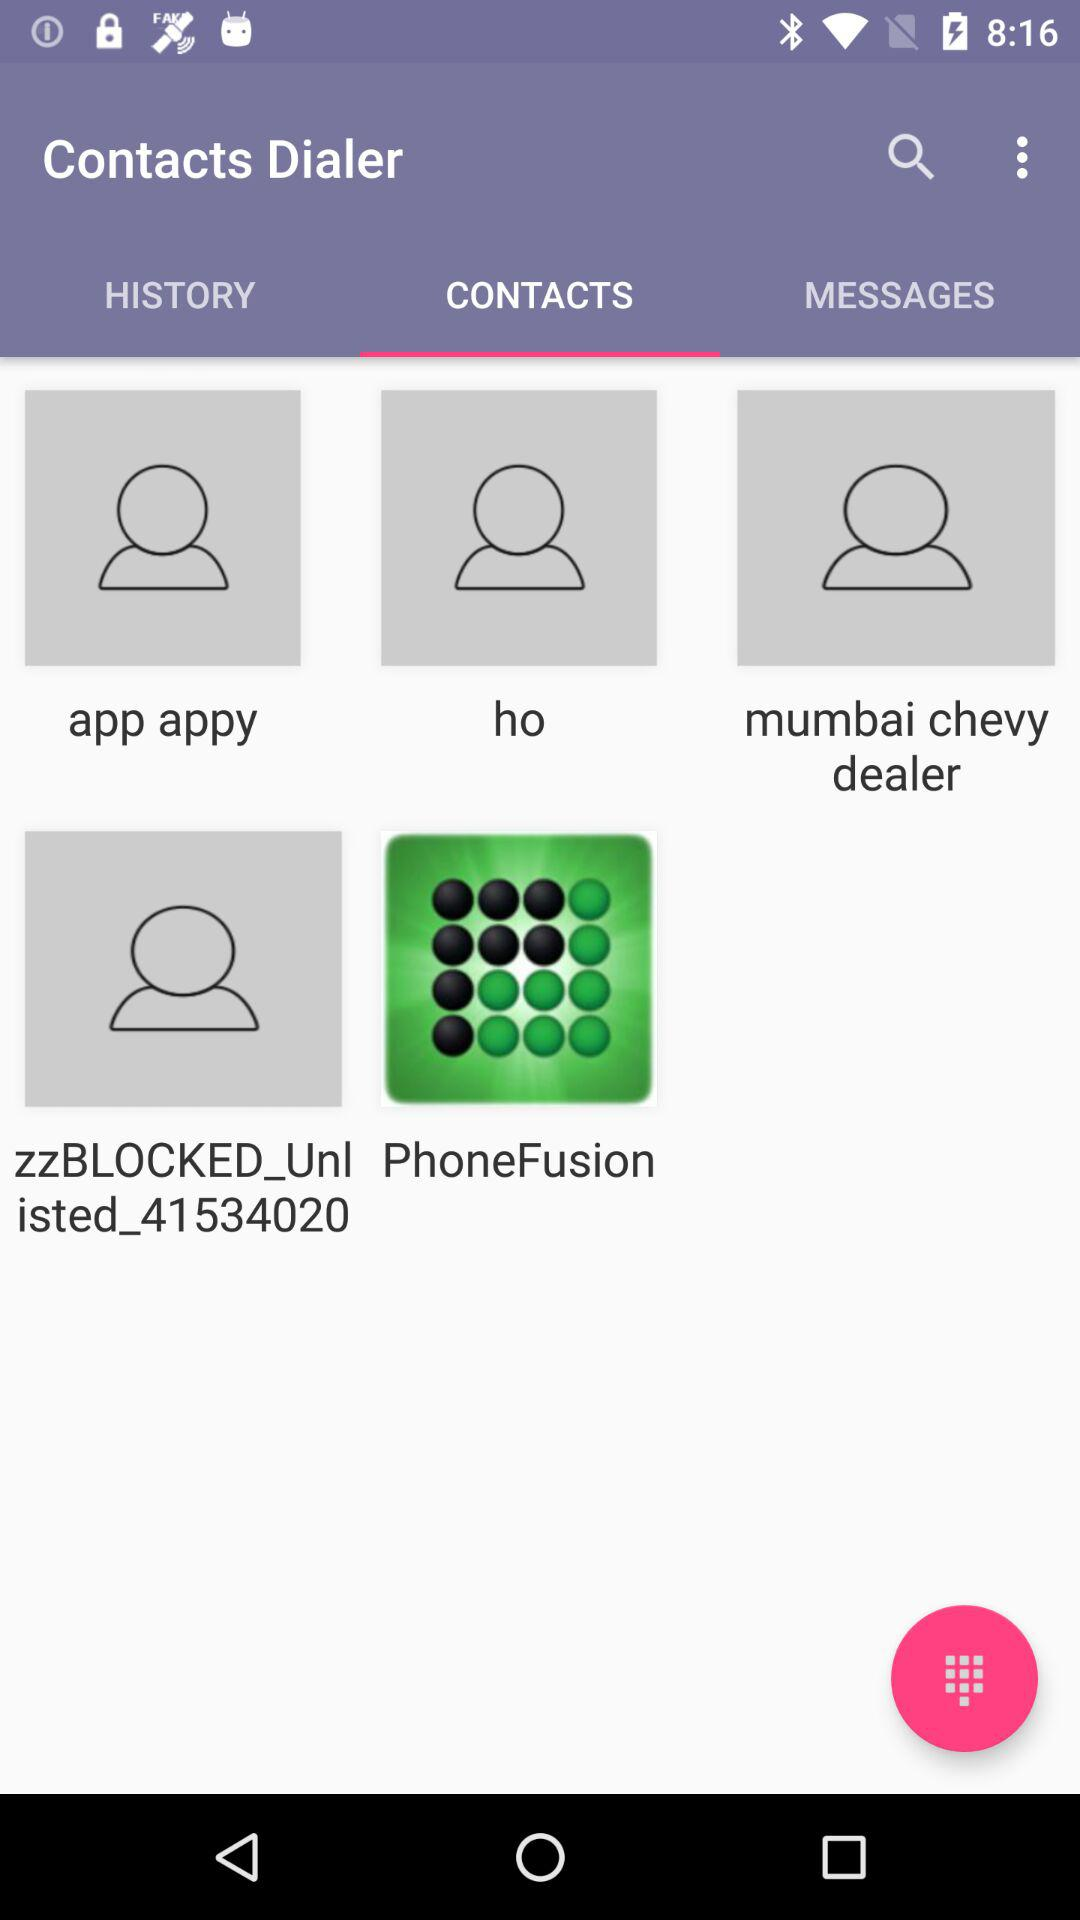What are the names of the contacts present in the contact list? The names of the contacts are "app appy", "ho", "mumbai chevy dealer", "zzBLOCKED_Unlisted_41534020" and "PhoneFusion". 